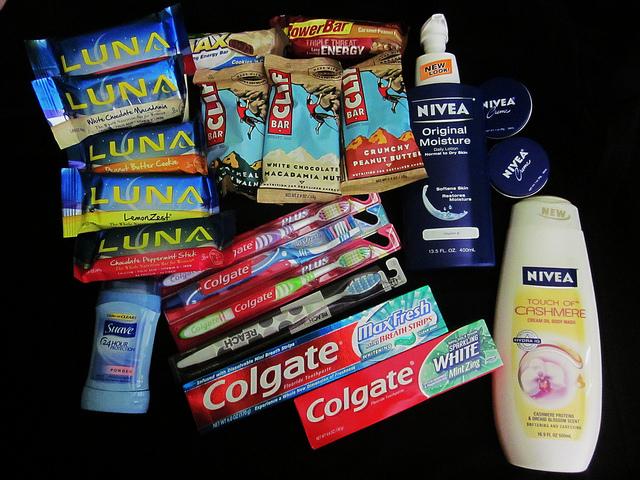Which item product category has the most variety of brands shown?
Short answer required. Luna. How many items are pictured?
Give a very brief answer. 21. How many of these items are marketed specifically to women?
Quick response, please. 2. What brand name is on the bottle?
Short answer required. Nivea. Is there anything edible?
Keep it brief. Yes. 